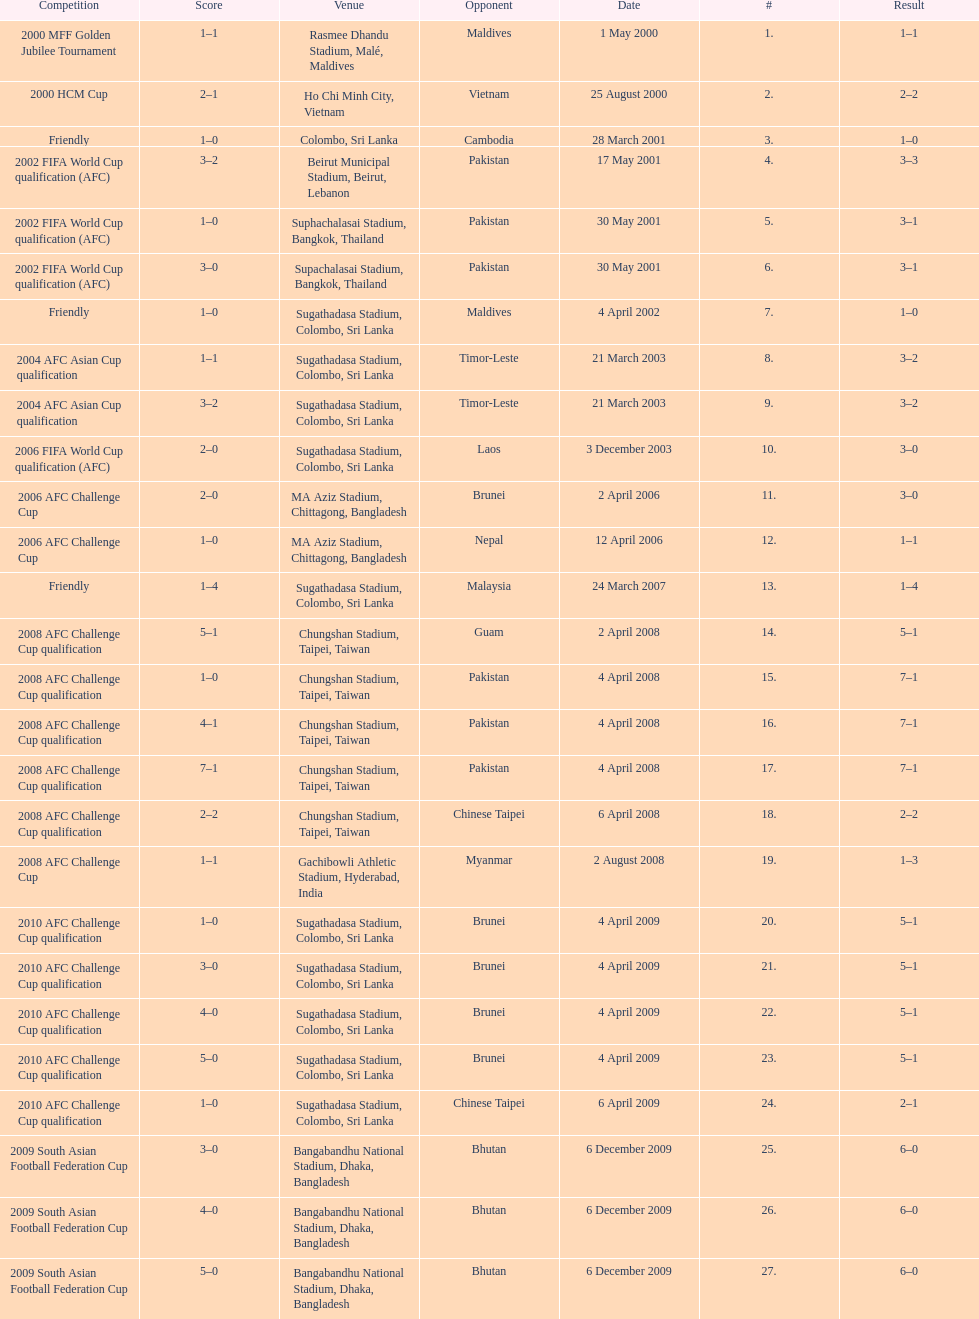Can you parse all the data within this table? {'header': ['Competition', 'Score', 'Venue', 'Opponent', 'Date', '#', 'Result'], 'rows': [['2000 MFF Golden Jubilee Tournament', '1–1', 'Rasmee Dhandu Stadium, Malé, Maldives', 'Maldives', '1 May 2000', '1.', '1–1'], ['2000 HCM Cup', '2–1', 'Ho Chi Minh City, Vietnam', 'Vietnam', '25 August 2000', '2.', '2–2'], ['Friendly', '1–0', 'Colombo, Sri Lanka', 'Cambodia', '28 March 2001', '3.', '1–0'], ['2002 FIFA World Cup qualification (AFC)', '3–2', 'Beirut Municipal Stadium, Beirut, Lebanon', 'Pakistan', '17 May 2001', '4.', '3–3'], ['2002 FIFA World Cup qualification (AFC)', '1–0', 'Suphachalasai Stadium, Bangkok, Thailand', 'Pakistan', '30 May 2001', '5.', '3–1'], ['2002 FIFA World Cup qualification (AFC)', '3–0', 'Supachalasai Stadium, Bangkok, Thailand', 'Pakistan', '30 May 2001', '6.', '3–1'], ['Friendly', '1–0', 'Sugathadasa Stadium, Colombo, Sri Lanka', 'Maldives', '4 April 2002', '7.', '1–0'], ['2004 AFC Asian Cup qualification', '1–1', 'Sugathadasa Stadium, Colombo, Sri Lanka', 'Timor-Leste', '21 March 2003', '8.', '3–2'], ['2004 AFC Asian Cup qualification', '3–2', 'Sugathadasa Stadium, Colombo, Sri Lanka', 'Timor-Leste', '21 March 2003', '9.', '3–2'], ['2006 FIFA World Cup qualification (AFC)', '2–0', 'Sugathadasa Stadium, Colombo, Sri Lanka', 'Laos', '3 December 2003', '10.', '3–0'], ['2006 AFC Challenge Cup', '2–0', 'MA Aziz Stadium, Chittagong, Bangladesh', 'Brunei', '2 April 2006', '11.', '3–0'], ['2006 AFC Challenge Cup', '1–0', 'MA Aziz Stadium, Chittagong, Bangladesh', 'Nepal', '12 April 2006', '12.', '1–1'], ['Friendly', '1–4', 'Sugathadasa Stadium, Colombo, Sri Lanka', 'Malaysia', '24 March 2007', '13.', '1–4'], ['2008 AFC Challenge Cup qualification', '5–1', 'Chungshan Stadium, Taipei, Taiwan', 'Guam', '2 April 2008', '14.', '5–1'], ['2008 AFC Challenge Cup qualification', '1–0', 'Chungshan Stadium, Taipei, Taiwan', 'Pakistan', '4 April 2008', '15.', '7–1'], ['2008 AFC Challenge Cup qualification', '4–1', 'Chungshan Stadium, Taipei, Taiwan', 'Pakistan', '4 April 2008', '16.', '7–1'], ['2008 AFC Challenge Cup qualification', '7–1', 'Chungshan Stadium, Taipei, Taiwan', 'Pakistan', '4 April 2008', '17.', '7–1'], ['2008 AFC Challenge Cup qualification', '2–2', 'Chungshan Stadium, Taipei, Taiwan', 'Chinese Taipei', '6 April 2008', '18.', '2–2'], ['2008 AFC Challenge Cup', '1–1', 'Gachibowli Athletic Stadium, Hyderabad, India', 'Myanmar', '2 August 2008', '19.', '1–3'], ['2010 AFC Challenge Cup qualification', '1–0', 'Sugathadasa Stadium, Colombo, Sri Lanka', 'Brunei', '4 April 2009', '20.', '5–1'], ['2010 AFC Challenge Cup qualification', '3–0', 'Sugathadasa Stadium, Colombo, Sri Lanka', 'Brunei', '4 April 2009', '21.', '5–1'], ['2010 AFC Challenge Cup qualification', '4–0', 'Sugathadasa Stadium, Colombo, Sri Lanka', 'Brunei', '4 April 2009', '22.', '5–1'], ['2010 AFC Challenge Cup qualification', '5–0', 'Sugathadasa Stadium, Colombo, Sri Lanka', 'Brunei', '4 April 2009', '23.', '5–1'], ['2010 AFC Challenge Cup qualification', '1–0', 'Sugathadasa Stadium, Colombo, Sri Lanka', 'Chinese Taipei', '6 April 2009', '24.', '2–1'], ['2009 South Asian Football Federation Cup', '3–0', 'Bangabandhu National Stadium, Dhaka, Bangladesh', 'Bhutan', '6 December 2009', '25.', '6–0'], ['2009 South Asian Football Federation Cup', '4–0', 'Bangabandhu National Stadium, Dhaka, Bangladesh', 'Bhutan', '6 December 2009', '26.', '6–0'], ['2009 South Asian Football Federation Cup', '5–0', 'Bangabandhu National Stadium, Dhaka, Bangladesh', 'Bhutan', '6 December 2009', '27.', '6–0']]} What was the total number of goals score in the sri lanka - malaysia game of march 24, 2007? 5. 